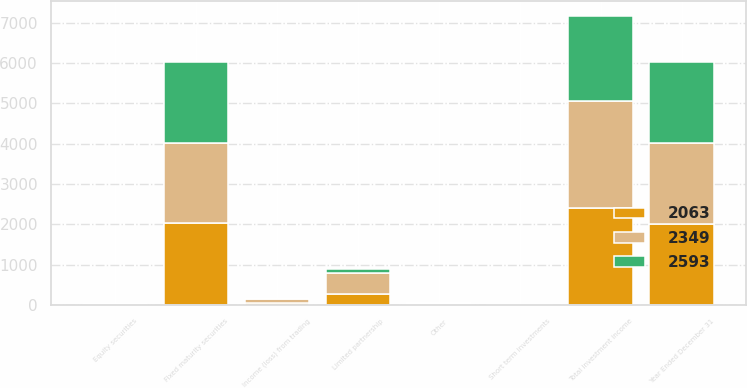Convert chart. <chart><loc_0><loc_0><loc_500><loc_500><stacked_bar_chart><ecel><fcel>Year Ended December 31<fcel>Fixed maturity securities<fcel>Short term investments<fcel>Limited partnership<fcel>Equity securities<fcel>Income (loss) from trading<fcel>Other<fcel>Total investment income<nl><fcel>2349<fcel>2013<fcel>1998<fcel>5<fcel>519<fcel>12<fcel>90<fcel>25<fcel>2649<nl><fcel>2063<fcel>2012<fcel>2022<fcel>12<fcel>283<fcel>12<fcel>52<fcel>24<fcel>2405<nl><fcel>2593<fcel>2011<fcel>2011<fcel>16<fcel>97<fcel>20<fcel>39<fcel>16<fcel>2121<nl></chart> 